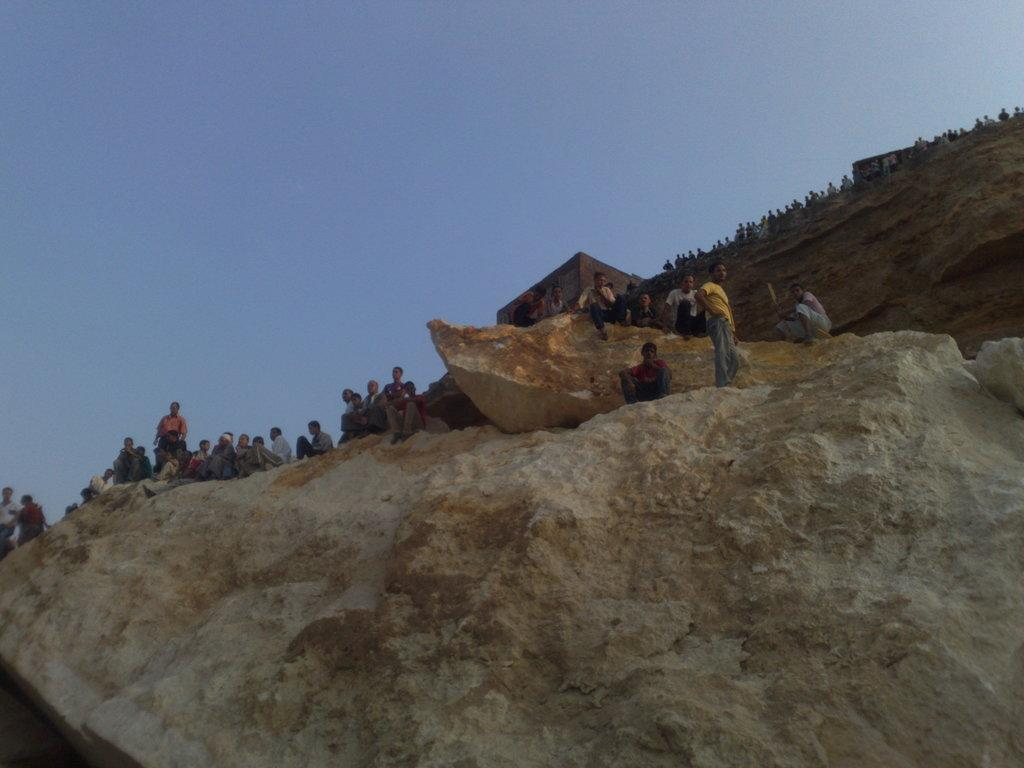What geographical feature is present in the image? There is a hill in the image. What are the people in the image doing? Some people are standing on the hill, while others are sitting on the hill. What is visible at the top of the image? The sky is visible at the top of the image. What type of plants are competing in the image? There is no competition or plants present in the image; it features a hill with people standing and sitting on it. 